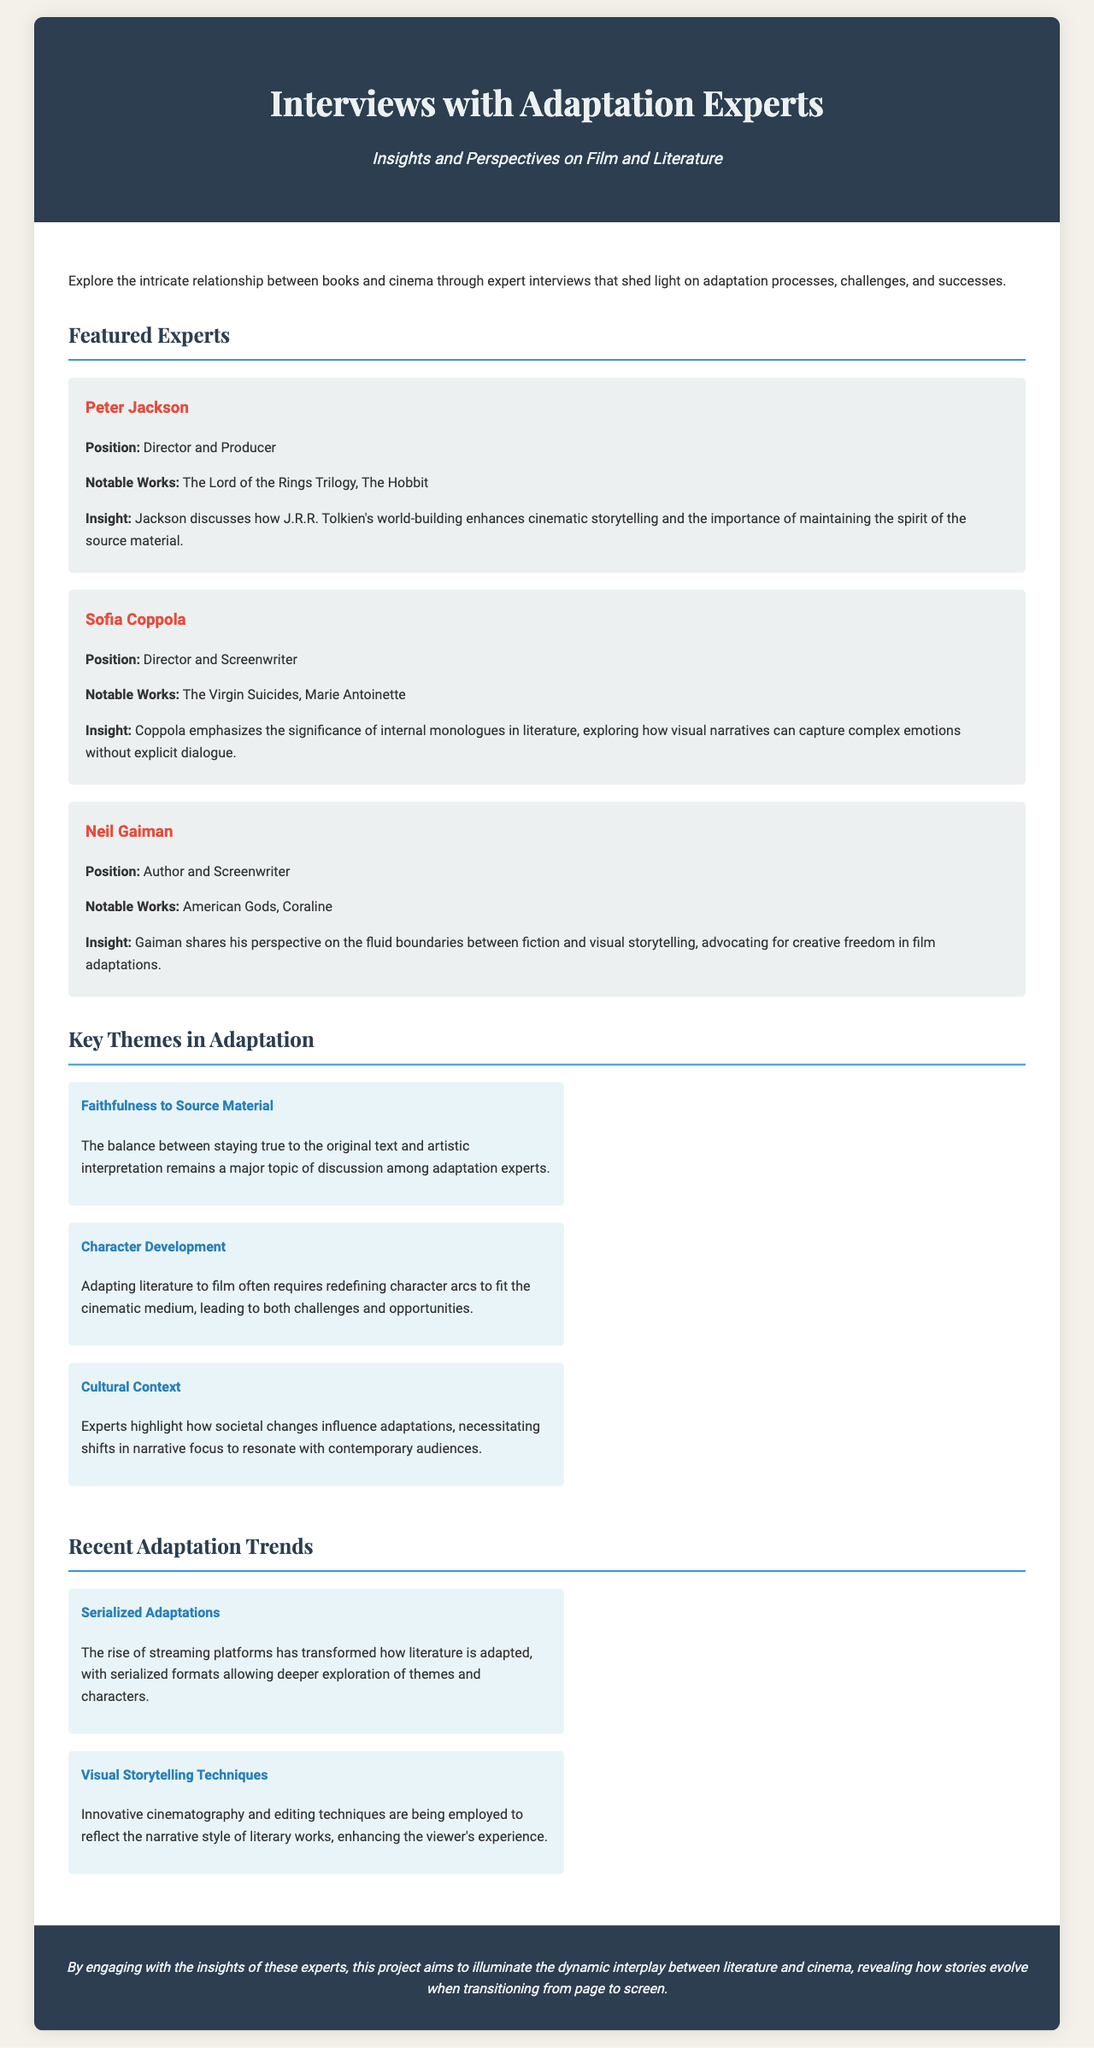What is the title of the brochure? The title is prominently displayed in the header section of the document.
Answer: Interviews with Adaptation Experts Who is a notable work of Neil Gaiman? Neil Gaiman's notable works are listed in his section within the featured experts.
Answer: American Gods What theme discusses the balance of original text and artistic interpretation? This theme is explicitly mentioned in the section on key themes in adaptation.
Answer: Faithfulness to Source Material Which director emphasizes the significance of internal monologues? This is highlighted in Sofia Coppola's section.
Answer: Sofia Coppola What adaptation trend relates to streaming platforms? The trend is stated under recent adaptation trends focusing on a new format.
Answer: Serialized Adaptations How many experts are featured in the brochure? The number of experts can be counted in the featured experts section of the document.
Answer: Three What position does Peter Jackson hold? Peter Jackson's position is explicitly stated in his introduction in the featured experts section.
Answer: Director and Producer What is the focus of the project described in the footer? The footer summarizes the aim of the project related to stories evolving in adaptations.
Answer: Dynamic interplay between literature and cinema 